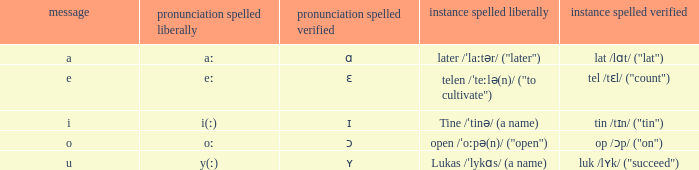What is Pronunciation Spelled Checked, when Example Spelled Checked is "tin /tɪn/ ("tin")" Ɪ. 